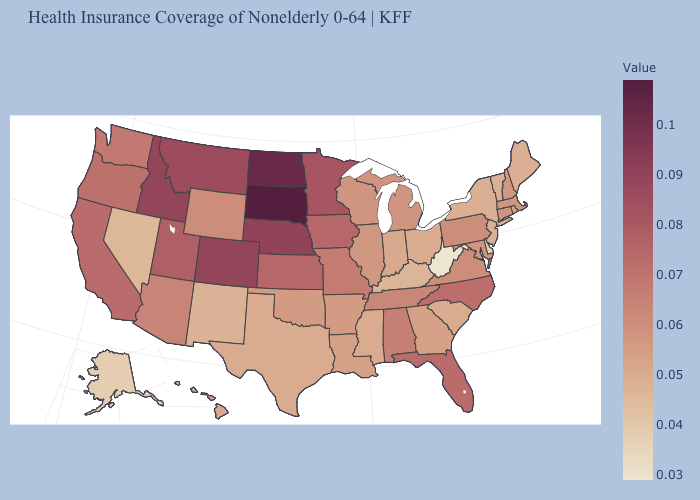Is the legend a continuous bar?
Keep it brief. Yes. Which states have the highest value in the USA?
Quick response, please. South Dakota. Which states hav the highest value in the Northeast?
Be succinct. Pennsylvania. Does West Virginia have the lowest value in the USA?
Concise answer only. Yes. Among the states that border South Carolina , which have the lowest value?
Give a very brief answer. Georgia. Does West Virginia have the lowest value in the South?
Give a very brief answer. Yes. 